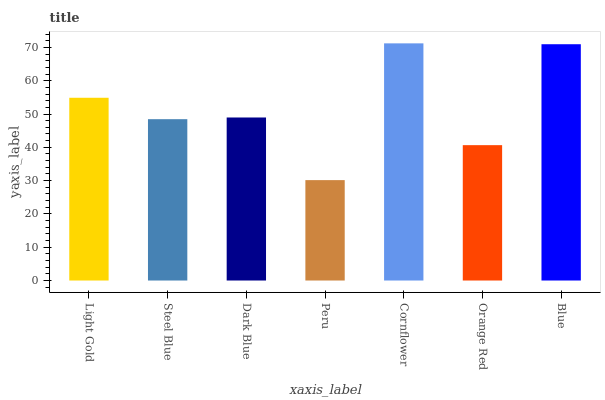Is Cornflower the maximum?
Answer yes or no. Yes. Is Steel Blue the minimum?
Answer yes or no. No. Is Steel Blue the maximum?
Answer yes or no. No. Is Light Gold greater than Steel Blue?
Answer yes or no. Yes. Is Steel Blue less than Light Gold?
Answer yes or no. Yes. Is Steel Blue greater than Light Gold?
Answer yes or no. No. Is Light Gold less than Steel Blue?
Answer yes or no. No. Is Dark Blue the high median?
Answer yes or no. Yes. Is Dark Blue the low median?
Answer yes or no. Yes. Is Cornflower the high median?
Answer yes or no. No. Is Peru the low median?
Answer yes or no. No. 